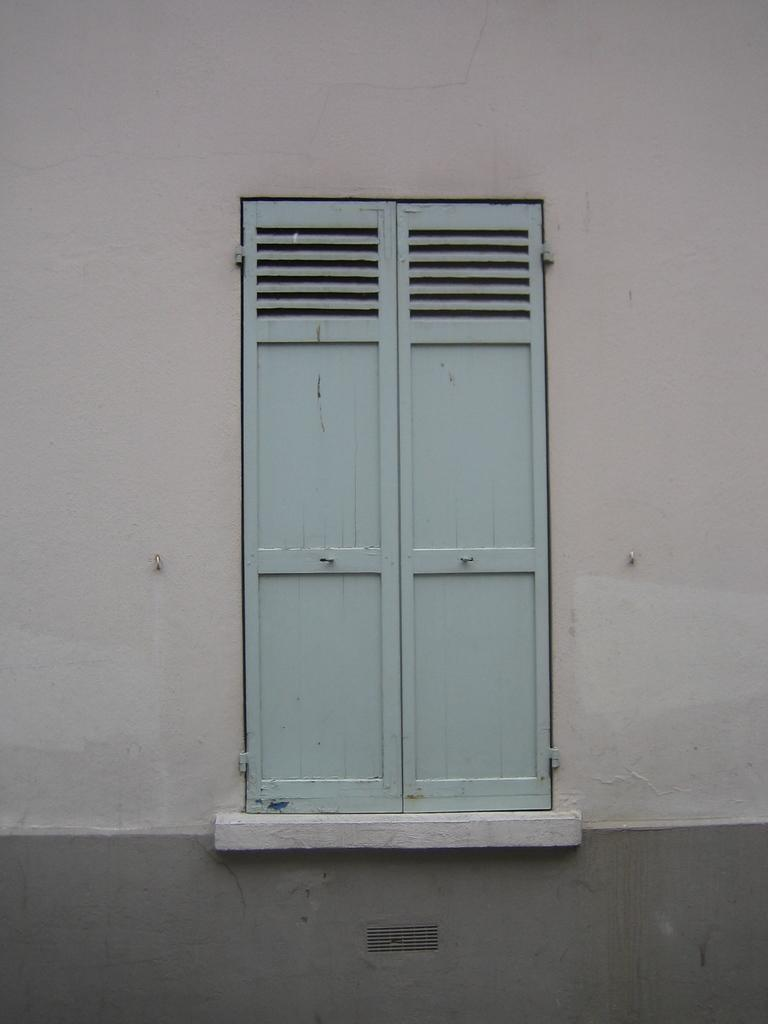What is located in the center of the image? There is a window in the center of the image. What else can be seen in the image? There is a wall in the image. What type of company is depicted in the image? There is no company depicted in the image; it only features a window and a wall. Can you see any trees in the image? There is no tree present in the image. 